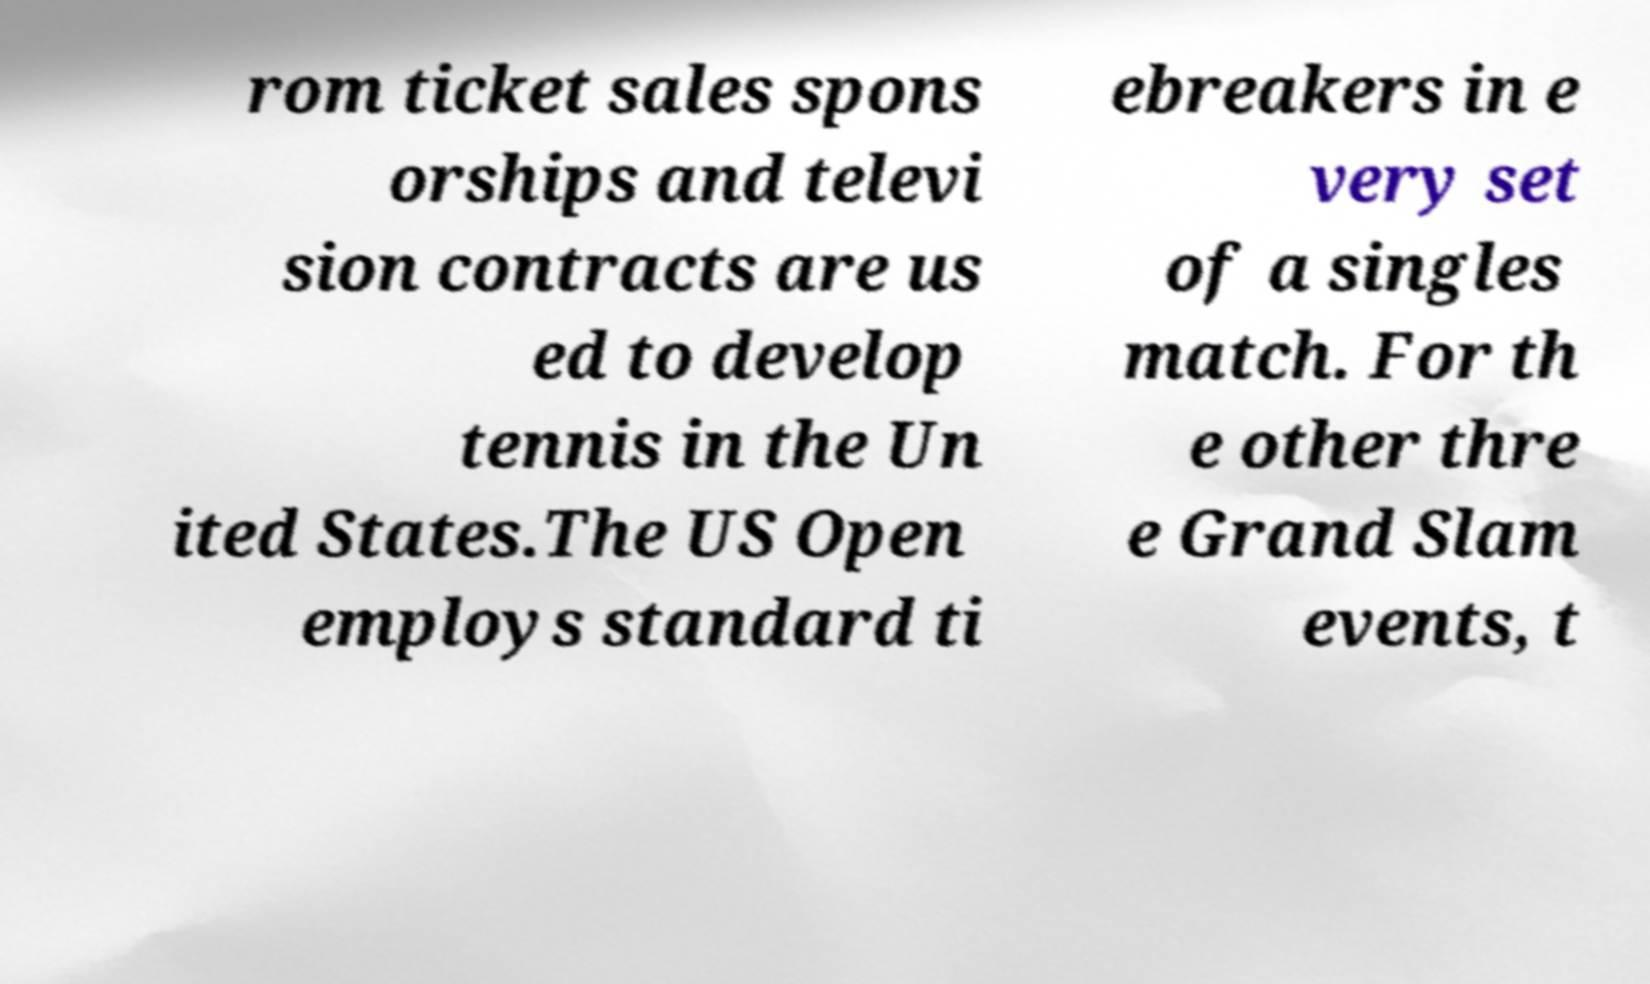Can you accurately transcribe the text from the provided image for me? rom ticket sales spons orships and televi sion contracts are us ed to develop tennis in the Un ited States.The US Open employs standard ti ebreakers in e very set of a singles match. For th e other thre e Grand Slam events, t 